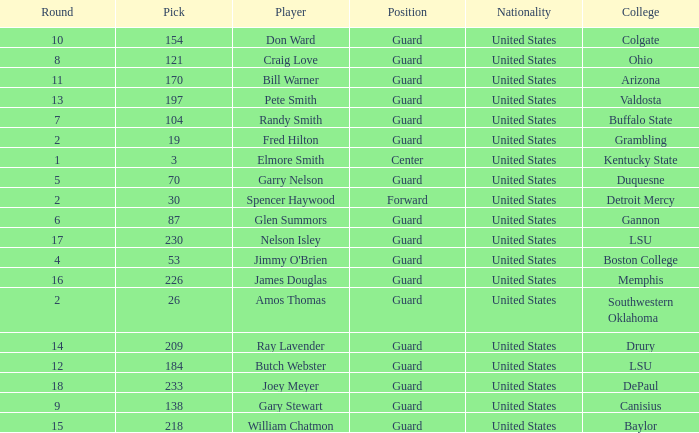Could you parse the entire table as a dict? {'header': ['Round', 'Pick', 'Player', 'Position', 'Nationality', 'College'], 'rows': [['10', '154', 'Don Ward', 'Guard', 'United States', 'Colgate'], ['8', '121', 'Craig Love', 'Guard', 'United States', 'Ohio'], ['11', '170', 'Bill Warner', 'Guard', 'United States', 'Arizona'], ['13', '197', 'Pete Smith', 'Guard', 'United States', 'Valdosta'], ['7', '104', 'Randy Smith', 'Guard', 'United States', 'Buffalo State'], ['2', '19', 'Fred Hilton', 'Guard', 'United States', 'Grambling'], ['1', '3', 'Elmore Smith', 'Center', 'United States', 'Kentucky State'], ['5', '70', 'Garry Nelson', 'Guard', 'United States', 'Duquesne'], ['2', '30', 'Spencer Haywood', 'Forward', 'United States', 'Detroit Mercy'], ['6', '87', 'Glen Summors', 'Guard', 'United States', 'Gannon'], ['17', '230', 'Nelson Isley', 'Guard', 'United States', 'LSU'], ['4', '53', "Jimmy O'Brien", 'Guard', 'United States', 'Boston College'], ['16', '226', 'James Douglas', 'Guard', 'United States', 'Memphis'], ['2', '26', 'Amos Thomas', 'Guard', 'United States', 'Southwestern Oklahoma'], ['14', '209', 'Ray Lavender', 'Guard', 'United States', 'Drury'], ['12', '184', 'Butch Webster', 'Guard', 'United States', 'LSU'], ['18', '233', 'Joey Meyer', 'Guard', 'United States', 'DePaul'], ['9', '138', 'Gary Stewart', 'Guard', 'United States', 'Canisius'], ['15', '218', 'William Chatmon', 'Guard', 'United States', 'Baylor']]} WHAT IS THE TOTAL PICK FOR BOSTON COLLEGE? 1.0. 